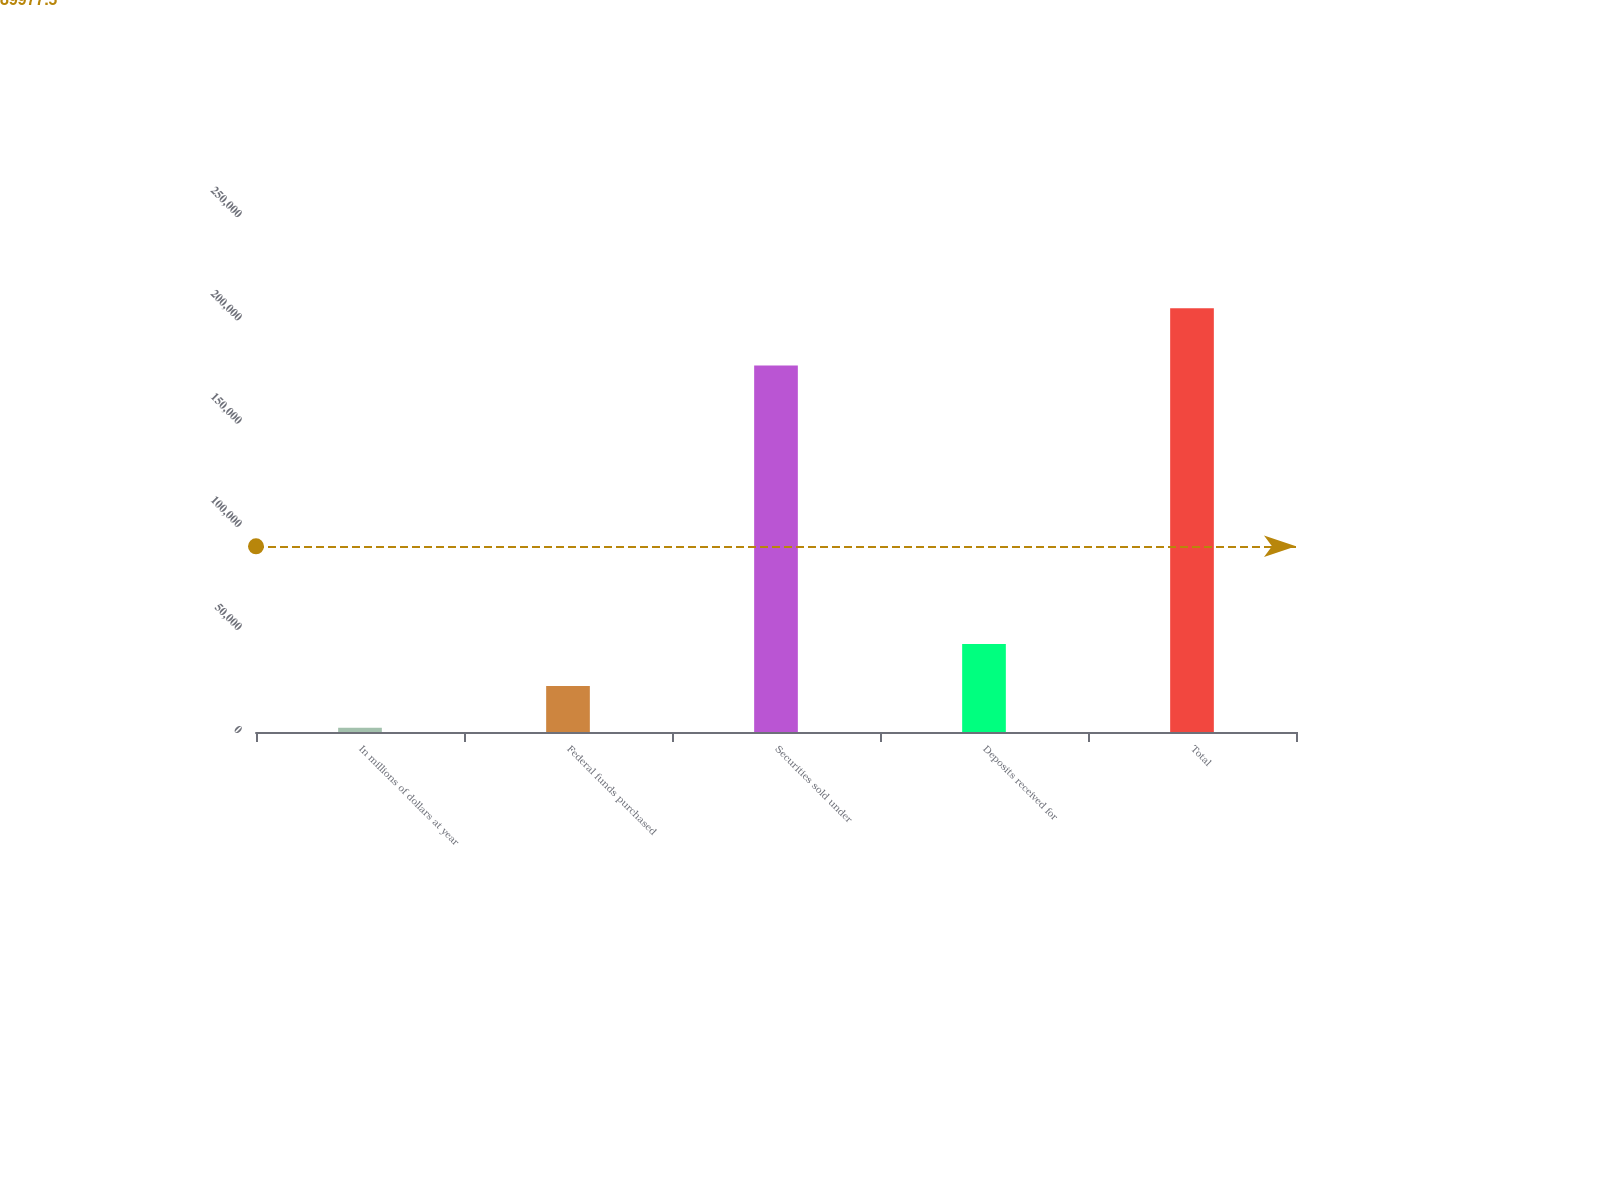Convert chart to OTSL. <chart><loc_0><loc_0><loc_500><loc_500><bar_chart><fcel>In millions of dollars at year<fcel>Federal funds purchased<fcel>Securities sold under<fcel>Deposits received for<fcel>Total<nl><fcel>2008<fcel>22336.5<fcel>177585<fcel>42665<fcel>205293<nl></chart> 